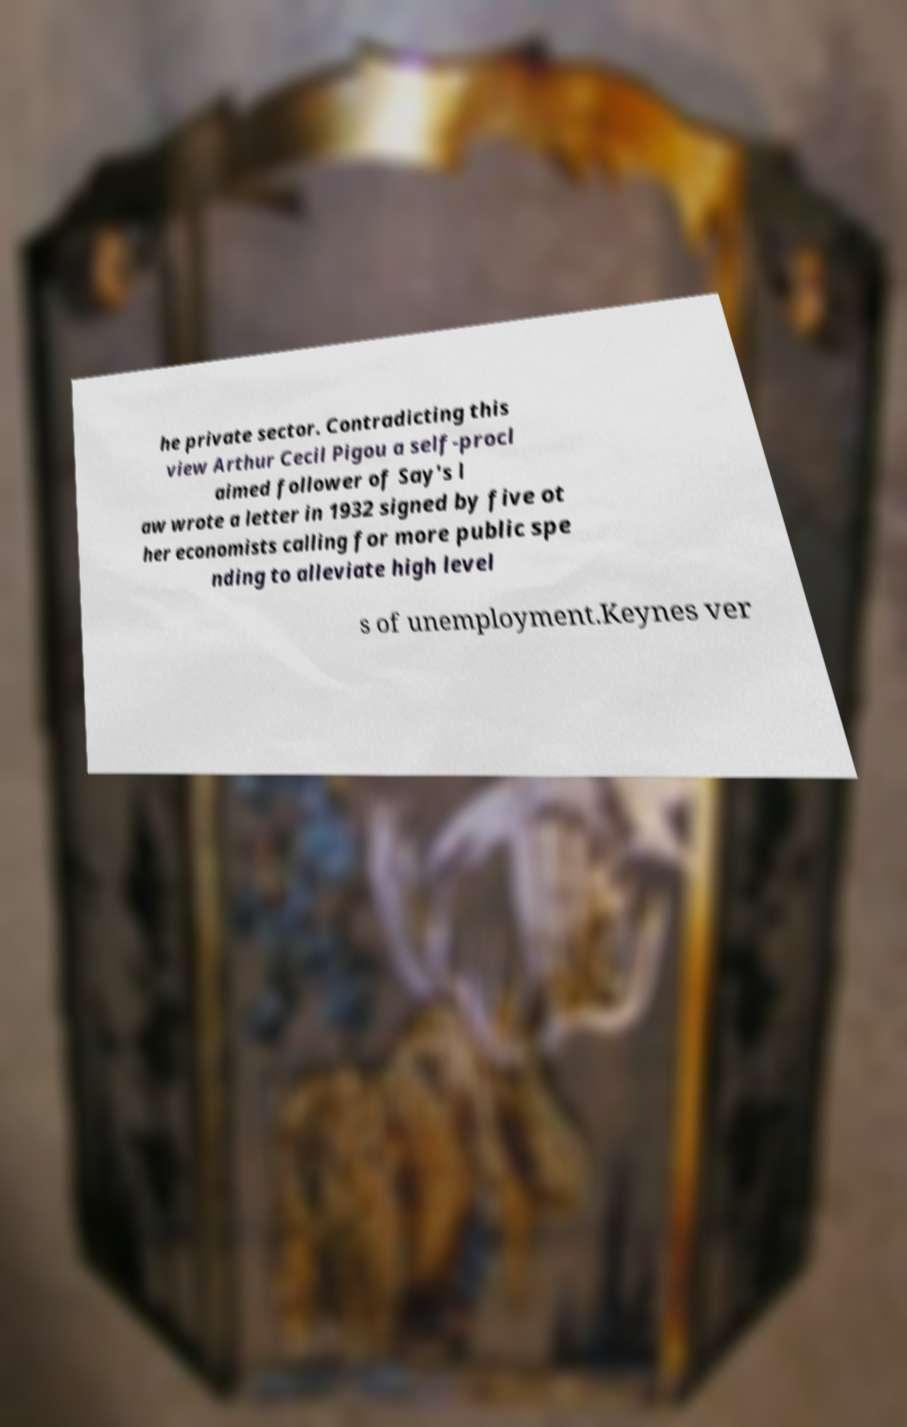There's text embedded in this image that I need extracted. Can you transcribe it verbatim? he private sector. Contradicting this view Arthur Cecil Pigou a self-procl aimed follower of Say's l aw wrote a letter in 1932 signed by five ot her economists calling for more public spe nding to alleviate high level s of unemployment.Keynes ver 